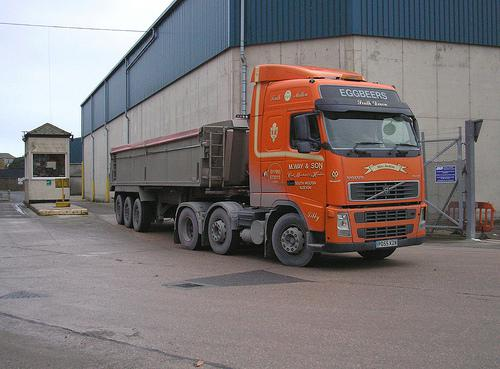Question: where is this shot?
Choices:
A. Zoo.
B. Park.
C. Factory.
D. Wedding.
Answer with the letter. Answer: C Question: how many wheels are there?
Choices:
A. 8.
B. 7.
C. 9.
D. 10.
Answer with the letter. Answer: B Question: how many animals are there?
Choices:
A. 0.
B. 1.
C. 2.
D. 3.
Answer with the letter. Answer: A 